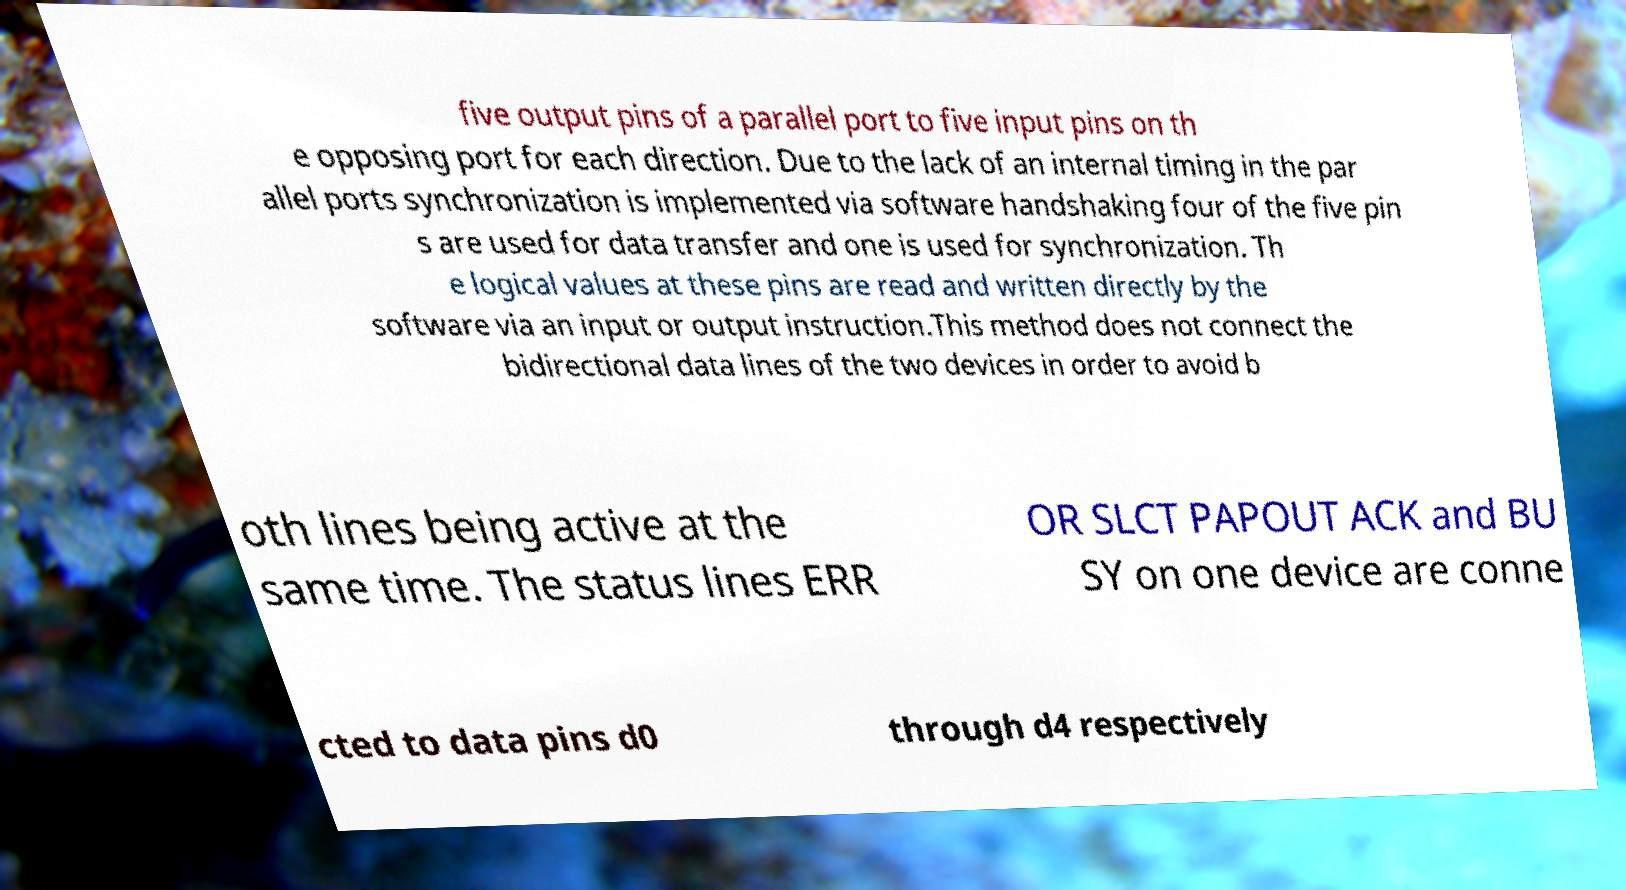I need the written content from this picture converted into text. Can you do that? five output pins of a parallel port to five input pins on th e opposing port for each direction. Due to the lack of an internal timing in the par allel ports synchronization is implemented via software handshaking four of the five pin s are used for data transfer and one is used for synchronization. Th e logical values at these pins are read and written directly by the software via an input or output instruction.This method does not connect the bidirectional data lines of the two devices in order to avoid b oth lines being active at the same time. The status lines ERR OR SLCT PAPOUT ACK and BU SY on one device are conne cted to data pins d0 through d4 respectively 